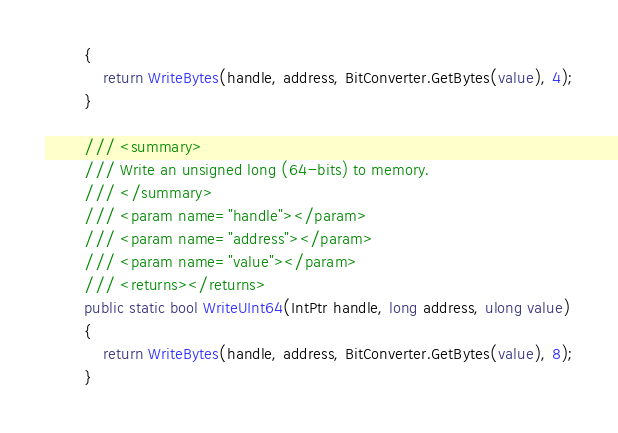<code> <loc_0><loc_0><loc_500><loc_500><_C#_>        {
            return WriteBytes(handle, address, BitConverter.GetBytes(value), 4);
        }

        /// <summary>
        /// Write an unsigned long (64-bits) to memory.
        /// </summary>
        /// <param name="handle"></param>
        /// <param name="address"></param>
        /// <param name="value"></param>
        /// <returns></returns>
        public static bool WriteUInt64(IntPtr handle, long address, ulong value)
        {
            return WriteBytes(handle, address, BitConverter.GetBytes(value), 8);
        }
</code> 